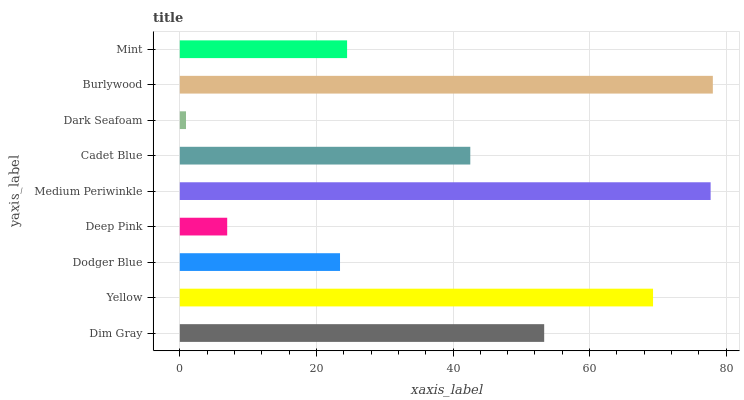Is Dark Seafoam the minimum?
Answer yes or no. Yes. Is Burlywood the maximum?
Answer yes or no. Yes. Is Yellow the minimum?
Answer yes or no. No. Is Yellow the maximum?
Answer yes or no. No. Is Yellow greater than Dim Gray?
Answer yes or no. Yes. Is Dim Gray less than Yellow?
Answer yes or no. Yes. Is Dim Gray greater than Yellow?
Answer yes or no. No. Is Yellow less than Dim Gray?
Answer yes or no. No. Is Cadet Blue the high median?
Answer yes or no. Yes. Is Cadet Blue the low median?
Answer yes or no. Yes. Is Dark Seafoam the high median?
Answer yes or no. No. Is Dim Gray the low median?
Answer yes or no. No. 